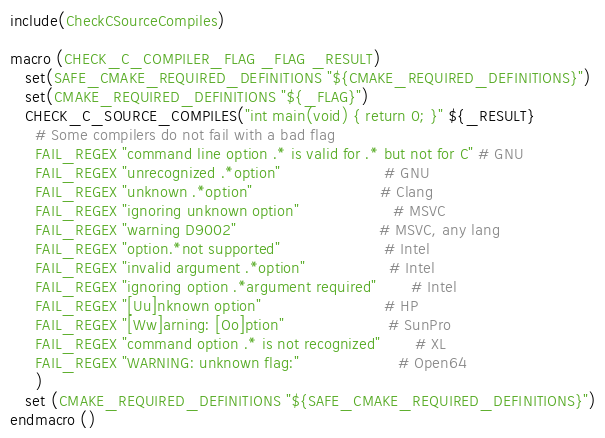Convert code to text. <code><loc_0><loc_0><loc_500><loc_500><_CMake_>
include(CheckCSourceCompiles)

macro (CHECK_C_COMPILER_FLAG _FLAG _RESULT)
   set(SAFE_CMAKE_REQUIRED_DEFINITIONS "${CMAKE_REQUIRED_DEFINITIONS}")
   set(CMAKE_REQUIRED_DEFINITIONS "${_FLAG}")
   CHECK_C_SOURCE_COMPILES("int main(void) { return 0; }" ${_RESULT}
     # Some compilers do not fail with a bad flag
     FAIL_REGEX "command line option .* is valid for .* but not for C" # GNU
     FAIL_REGEX "unrecognized .*option"                     # GNU
     FAIL_REGEX "unknown .*option"                          # Clang
     FAIL_REGEX "ignoring unknown option"                   # MSVC
     FAIL_REGEX "warning D9002"                             # MSVC, any lang
     FAIL_REGEX "option.*not supported"                     # Intel
     FAIL_REGEX "invalid argument .*option"                 # Intel
     FAIL_REGEX "ignoring option .*argument required"       # Intel
     FAIL_REGEX "[Uu]nknown option"                         # HP
     FAIL_REGEX "[Ww]arning: [Oo]ption"                     # SunPro
     FAIL_REGEX "command option .* is not recognized"       # XL
     FAIL_REGEX "WARNING: unknown flag:"                    # Open64
     )
   set (CMAKE_REQUIRED_DEFINITIONS "${SAFE_CMAKE_REQUIRED_DEFINITIONS}")
endmacro ()
</code> 